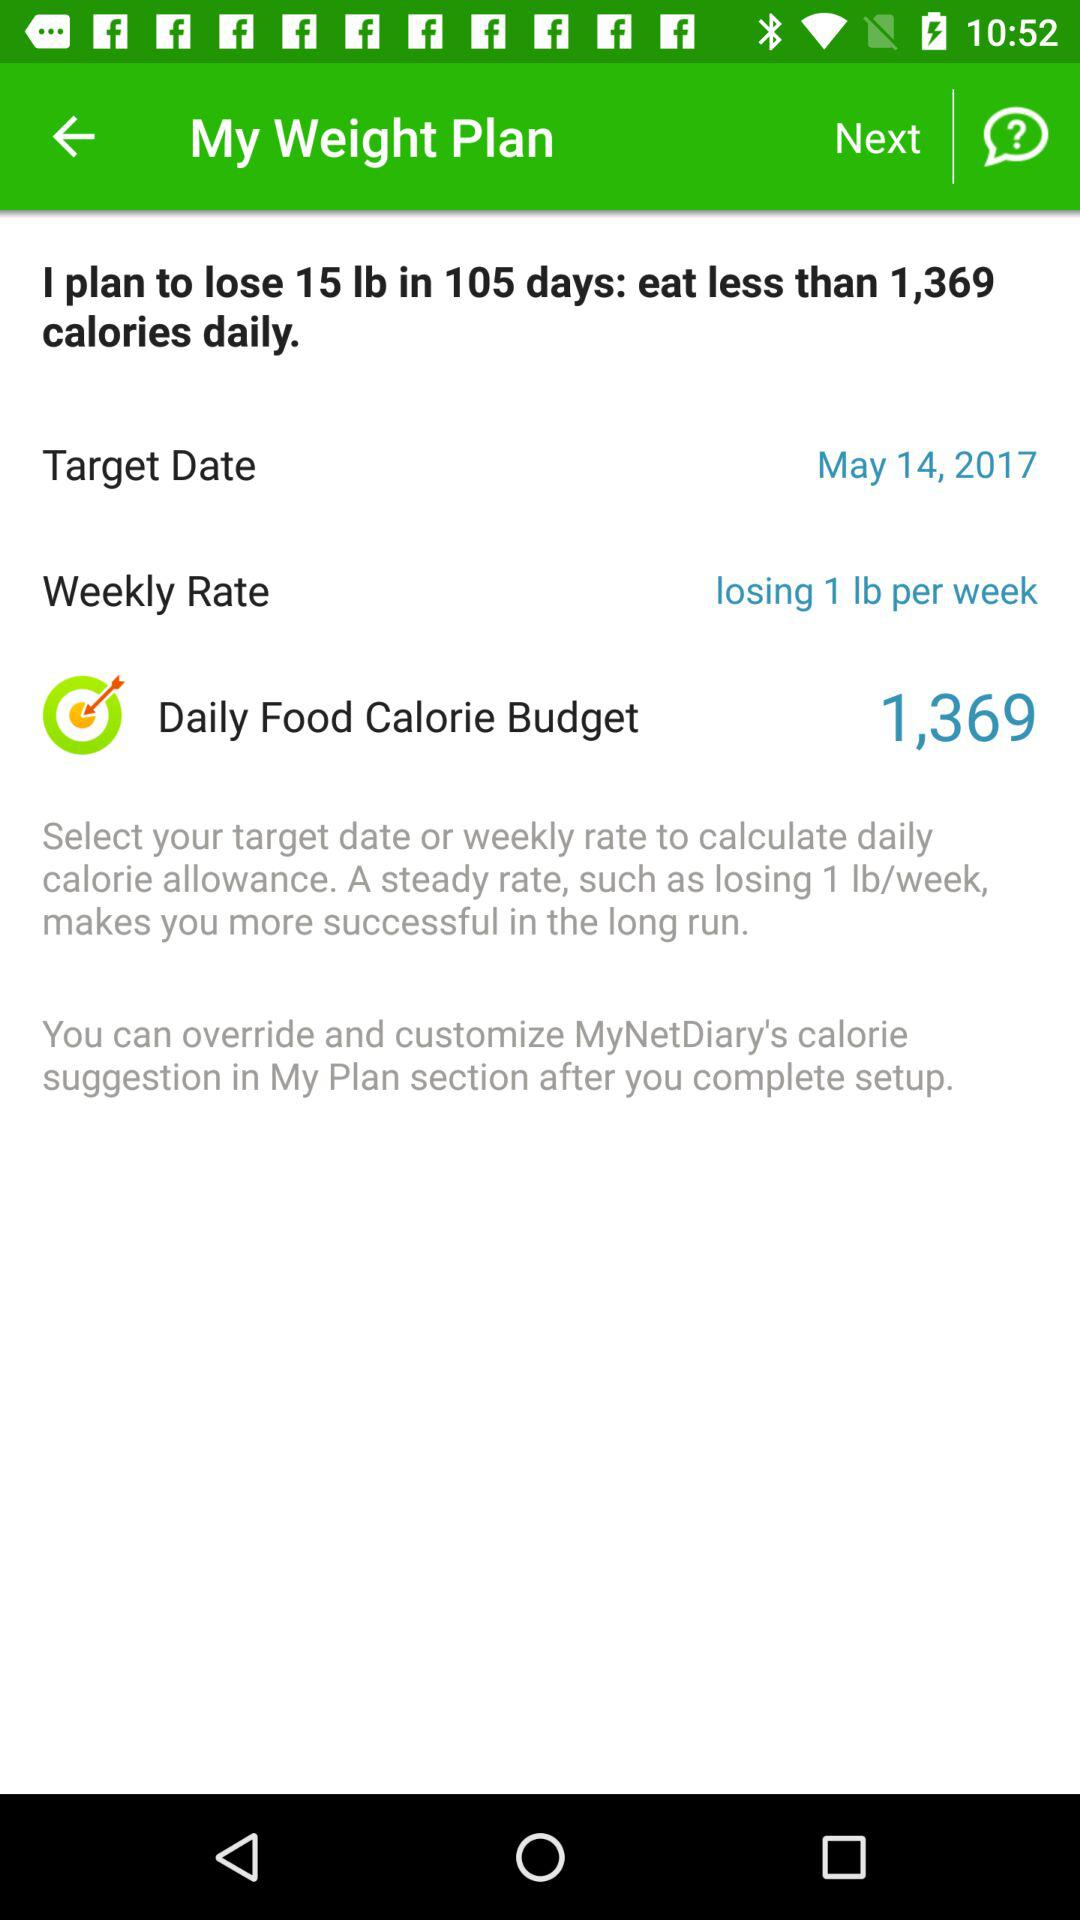What is the "Daily Food Calorie Budget"? The daily food calorie budget is 1,369. 